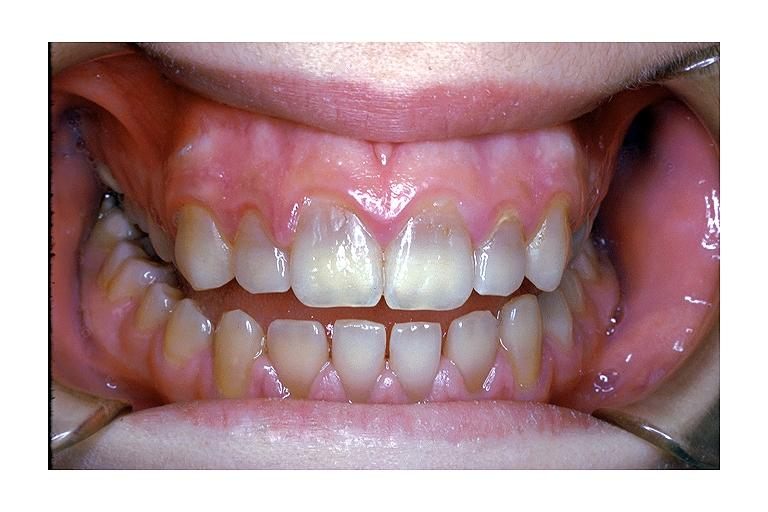s supernumerary digits induced discoloration?
Answer the question using a single word or phrase. No 